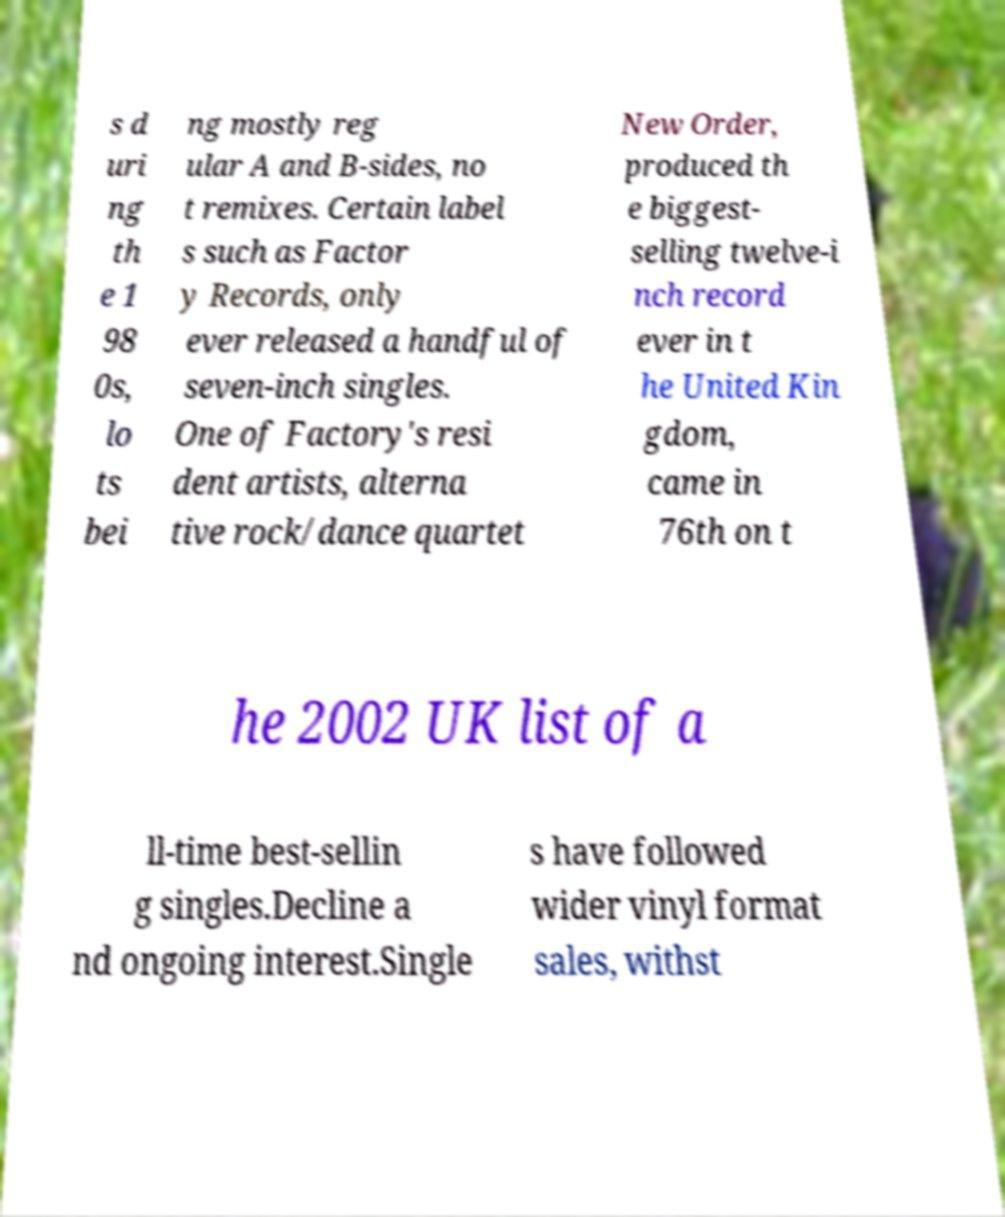Please read and relay the text visible in this image. What does it say? s d uri ng th e 1 98 0s, lo ts bei ng mostly reg ular A and B-sides, no t remixes. Certain label s such as Factor y Records, only ever released a handful of seven-inch singles. One of Factory's resi dent artists, alterna tive rock/dance quartet New Order, produced th e biggest- selling twelve-i nch record ever in t he United Kin gdom, came in 76th on t he 2002 UK list of a ll-time best-sellin g singles.Decline a nd ongoing interest.Single s have followed wider vinyl format sales, withst 